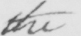What does this handwritten line say? the 